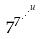<formula> <loc_0><loc_0><loc_500><loc_500>7 ^ { 7 ^ { \cdot ^ { \cdot ^ { \cdot ^ { u } } } } }</formula> 